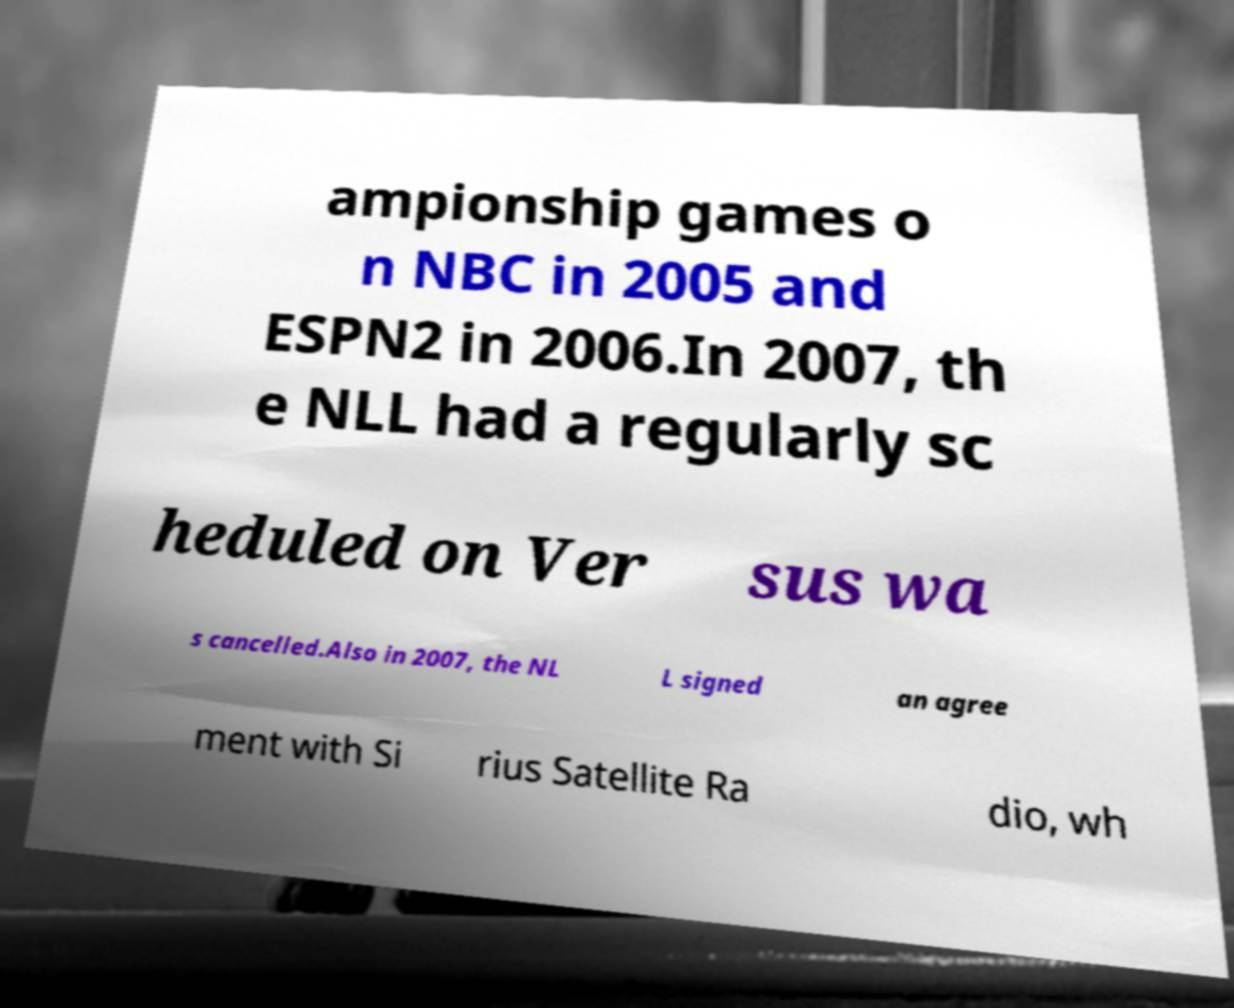What messages or text are displayed in this image? I need them in a readable, typed format. ampionship games o n NBC in 2005 and ESPN2 in 2006.In 2007, th e NLL had a regularly sc heduled on Ver sus wa s cancelled.Also in 2007, the NL L signed an agree ment with Si rius Satellite Ra dio, wh 